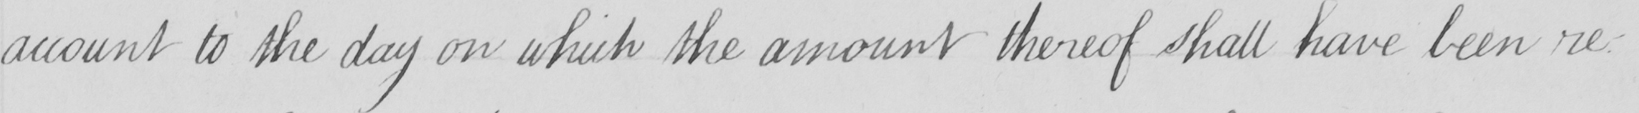Can you read and transcribe this handwriting? account to the day on which the amount thereof shall have been re- 